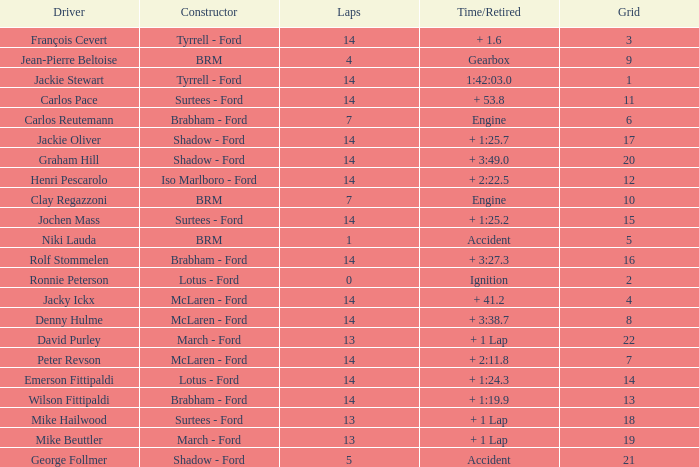What is the low lap total for henri pescarolo with a grad larger than 6? 14.0. 